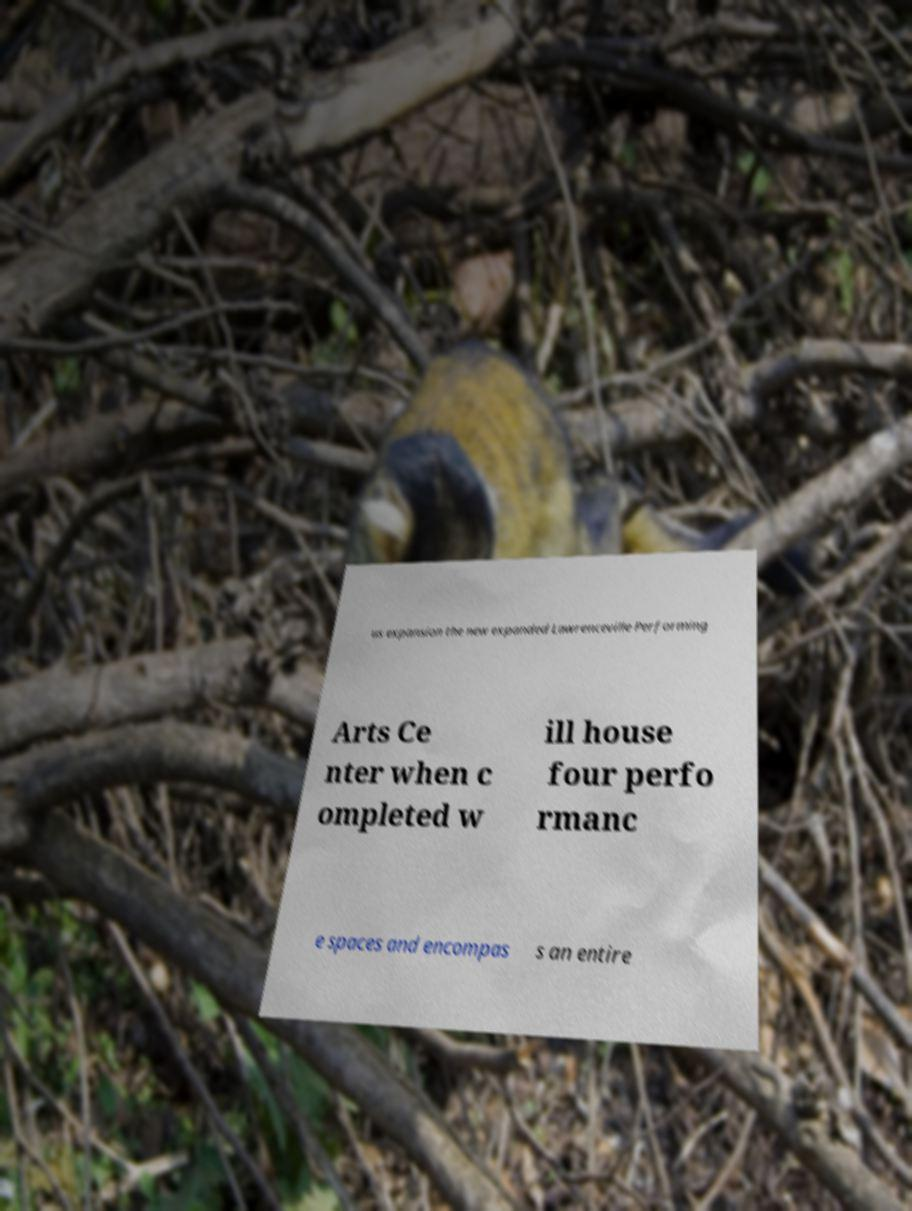Please identify and transcribe the text found in this image. us expansion the new expanded Lawrenceville Performing Arts Ce nter when c ompleted w ill house four perfo rmanc e spaces and encompas s an entire 